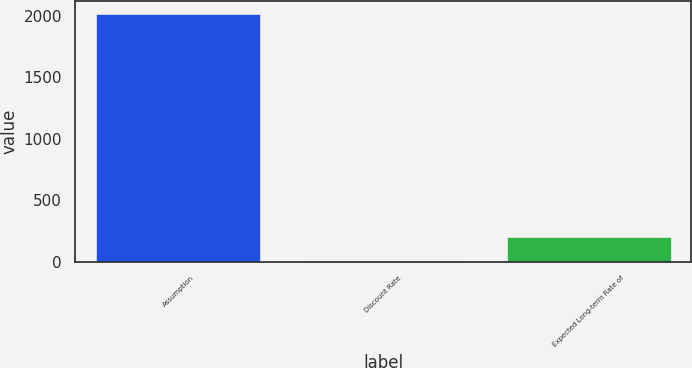Convert chart. <chart><loc_0><loc_0><loc_500><loc_500><bar_chart><fcel>Assumption<fcel>Discount Rate<fcel>Expected Long-term Rate of<nl><fcel>2017<fcel>4.2<fcel>205.48<nl></chart> 